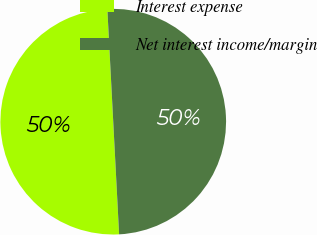Convert chart to OTSL. <chart><loc_0><loc_0><loc_500><loc_500><pie_chart><fcel>Interest expense<fcel>Net interest income/margin<nl><fcel>50.0%<fcel>50.0%<nl></chart> 